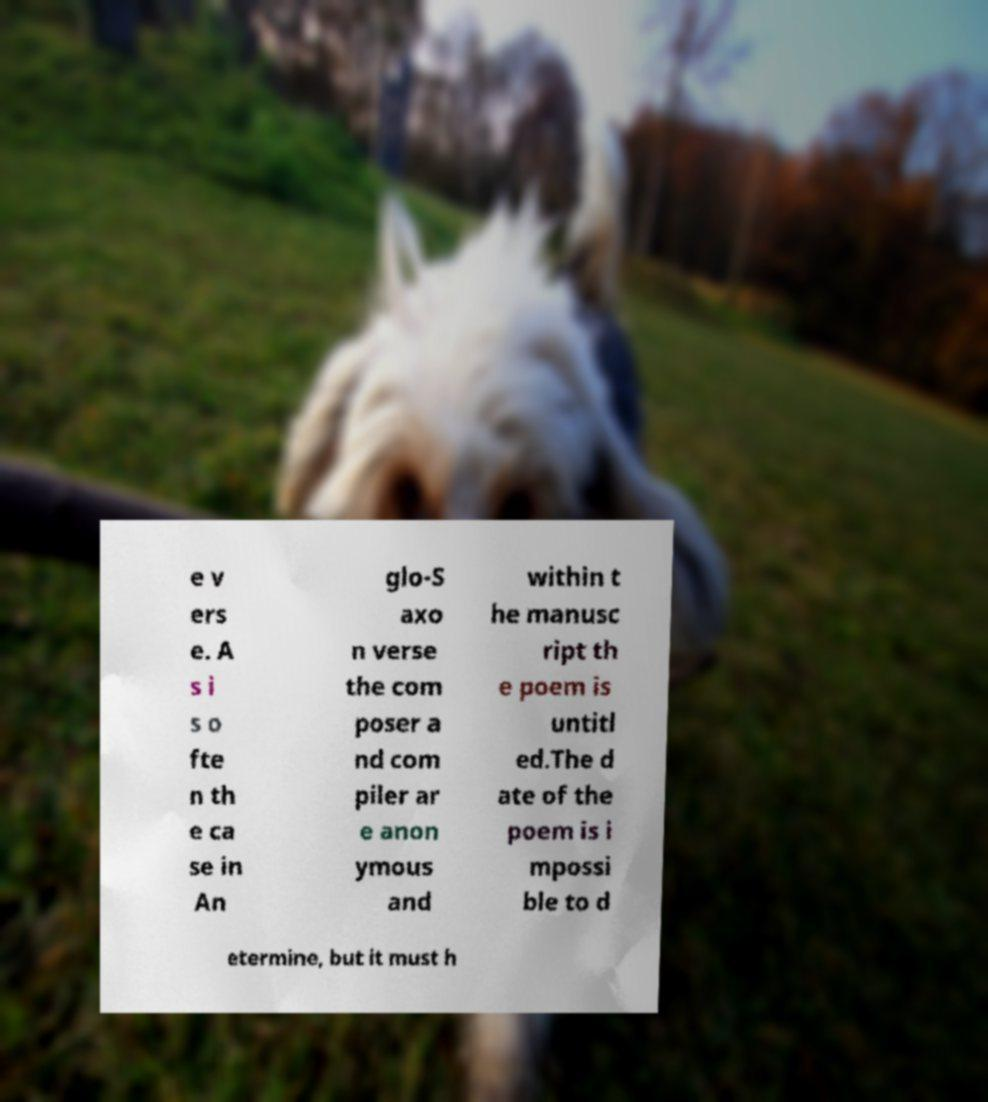Please identify and transcribe the text found in this image. e v ers e. A s i s o fte n th e ca se in An glo-S axo n verse the com poser a nd com piler ar e anon ymous and within t he manusc ript th e poem is untitl ed.The d ate of the poem is i mpossi ble to d etermine, but it must h 